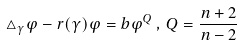Convert formula to latex. <formula><loc_0><loc_0><loc_500><loc_500>\triangle _ { \gamma } \varphi - r ( \gamma ) \varphi = b \varphi ^ { Q } \, , \, Q = \frac { n + 2 } { n - 2 }</formula> 